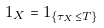Convert formula to latex. <formula><loc_0><loc_0><loc_500><loc_500>1 _ { X } = 1 _ { \{ \tau _ { X } \leq T \} }</formula> 